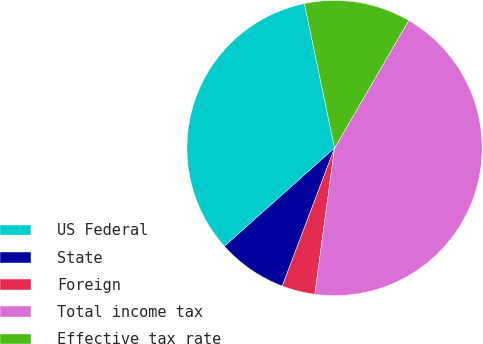Convert chart to OTSL. <chart><loc_0><loc_0><loc_500><loc_500><pie_chart><fcel>US Federal<fcel>State<fcel>Foreign<fcel>Total income tax<fcel>Effective tax rate<nl><fcel>33.32%<fcel>7.64%<fcel>3.63%<fcel>43.75%<fcel>11.66%<nl></chart> 